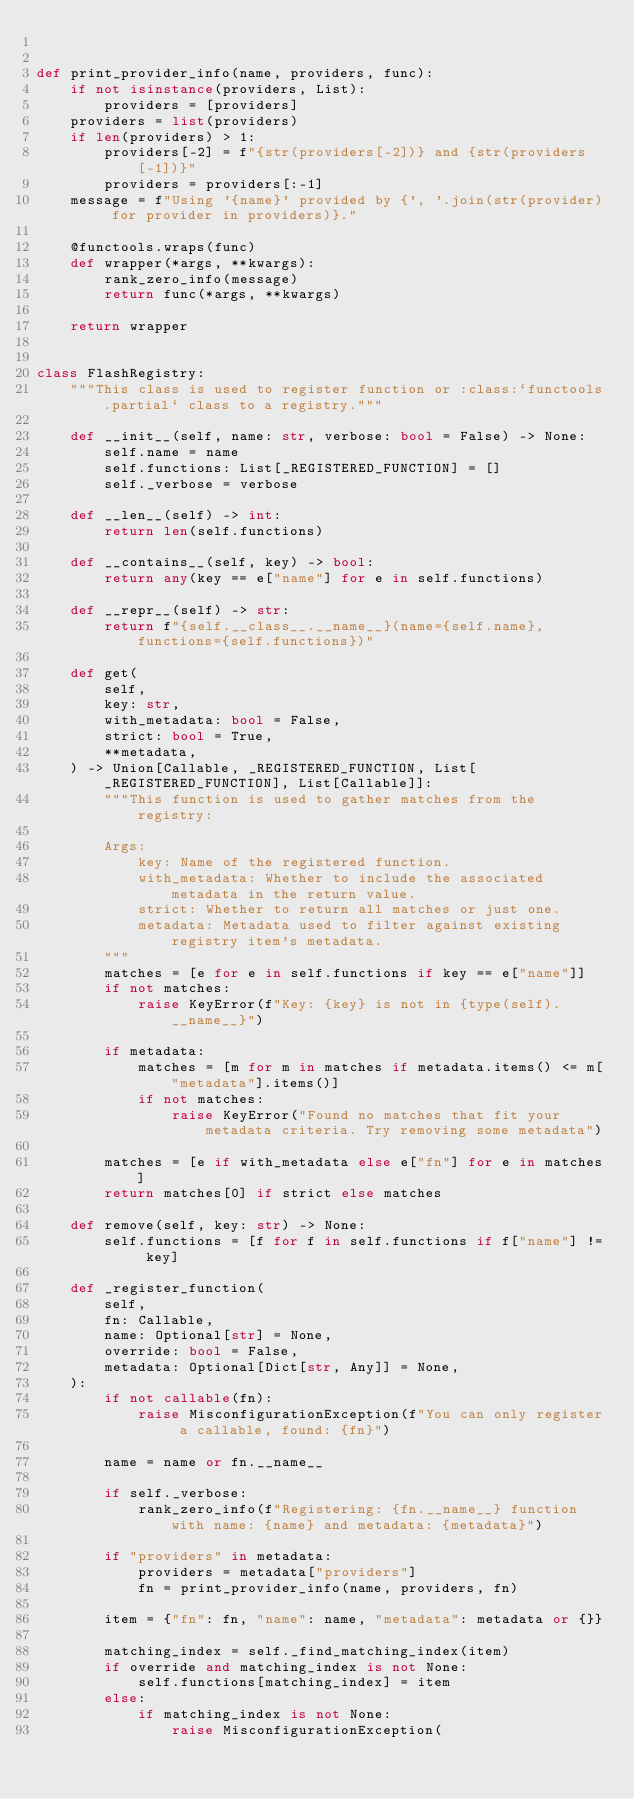Convert code to text. <code><loc_0><loc_0><loc_500><loc_500><_Python_>

def print_provider_info(name, providers, func):
    if not isinstance(providers, List):
        providers = [providers]
    providers = list(providers)
    if len(providers) > 1:
        providers[-2] = f"{str(providers[-2])} and {str(providers[-1])}"
        providers = providers[:-1]
    message = f"Using '{name}' provided by {', '.join(str(provider) for provider in providers)}."

    @functools.wraps(func)
    def wrapper(*args, **kwargs):
        rank_zero_info(message)
        return func(*args, **kwargs)

    return wrapper


class FlashRegistry:
    """This class is used to register function or :class:`functools.partial` class to a registry."""

    def __init__(self, name: str, verbose: bool = False) -> None:
        self.name = name
        self.functions: List[_REGISTERED_FUNCTION] = []
        self._verbose = verbose

    def __len__(self) -> int:
        return len(self.functions)

    def __contains__(self, key) -> bool:
        return any(key == e["name"] for e in self.functions)

    def __repr__(self) -> str:
        return f"{self.__class__.__name__}(name={self.name}, functions={self.functions})"

    def get(
        self,
        key: str,
        with_metadata: bool = False,
        strict: bool = True,
        **metadata,
    ) -> Union[Callable, _REGISTERED_FUNCTION, List[_REGISTERED_FUNCTION], List[Callable]]:
        """This function is used to gather matches from the registry:

        Args:
            key: Name of the registered function.
            with_metadata: Whether to include the associated metadata in the return value.
            strict: Whether to return all matches or just one.
            metadata: Metadata used to filter against existing registry item's metadata.
        """
        matches = [e for e in self.functions if key == e["name"]]
        if not matches:
            raise KeyError(f"Key: {key} is not in {type(self).__name__}")

        if metadata:
            matches = [m for m in matches if metadata.items() <= m["metadata"].items()]
            if not matches:
                raise KeyError("Found no matches that fit your metadata criteria. Try removing some metadata")

        matches = [e if with_metadata else e["fn"] for e in matches]
        return matches[0] if strict else matches

    def remove(self, key: str) -> None:
        self.functions = [f for f in self.functions if f["name"] != key]

    def _register_function(
        self,
        fn: Callable,
        name: Optional[str] = None,
        override: bool = False,
        metadata: Optional[Dict[str, Any]] = None,
    ):
        if not callable(fn):
            raise MisconfigurationException(f"You can only register a callable, found: {fn}")

        name = name or fn.__name__

        if self._verbose:
            rank_zero_info(f"Registering: {fn.__name__} function with name: {name} and metadata: {metadata}")

        if "providers" in metadata:
            providers = metadata["providers"]
            fn = print_provider_info(name, providers, fn)

        item = {"fn": fn, "name": name, "metadata": metadata or {}}

        matching_index = self._find_matching_index(item)
        if override and matching_index is not None:
            self.functions[matching_index] = item
        else:
            if matching_index is not None:
                raise MisconfigurationException(</code> 